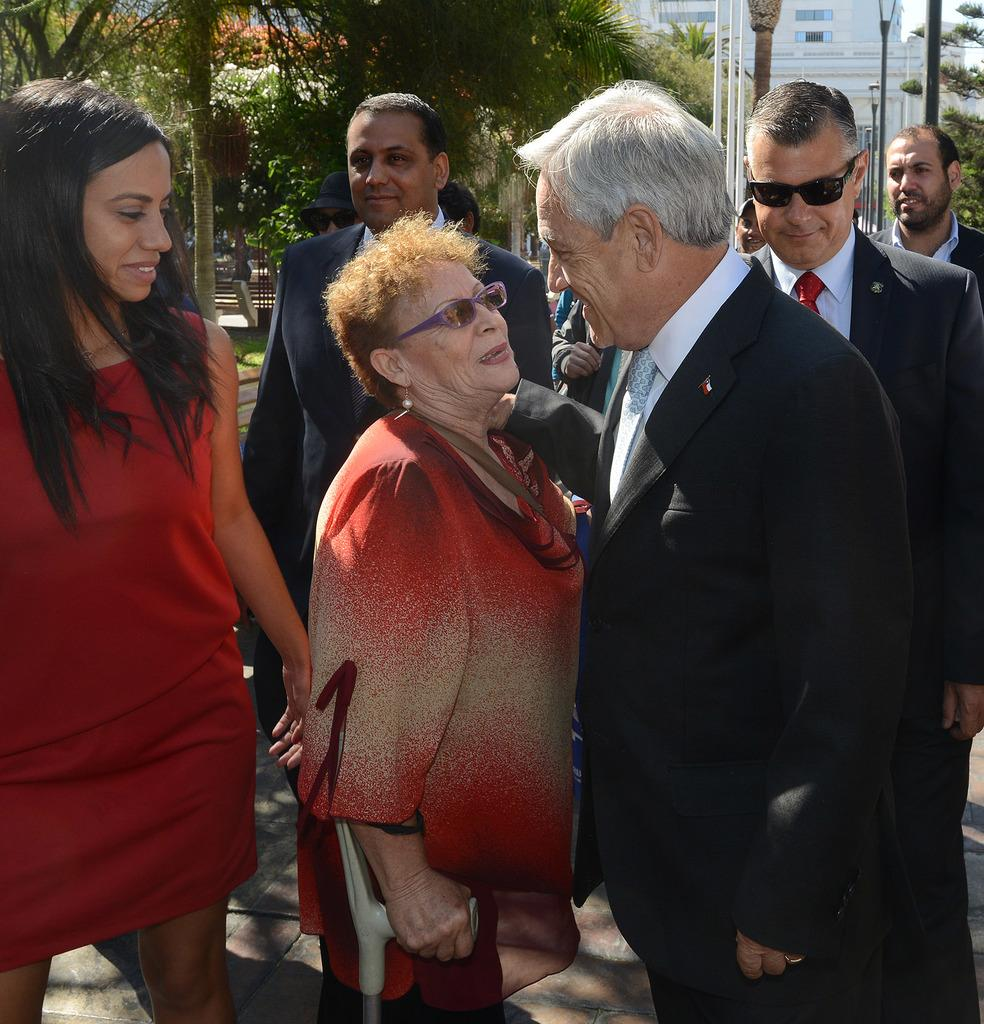What can be seen in the image? There are persons standing in the image. What is visible in the background of the image? There are trees, poles, buildings, windows, and objects in the background of the image. What type of stew is being served at the event in the image? There is no event or stew present in the image; it only shows persons standing and elements in the background. 